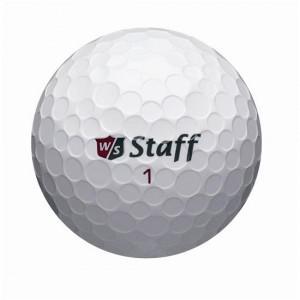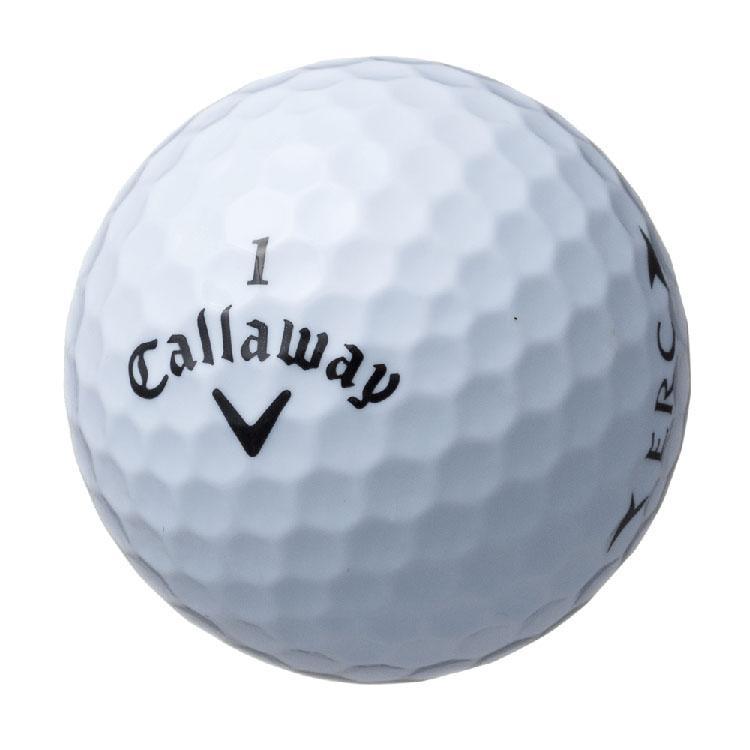The first image is the image on the left, the second image is the image on the right. Given the left and right images, does the statement "In one of the images there is a golf ball with a face printed on it." hold true? Answer yes or no. No. The first image is the image on the left, the second image is the image on the right. Assess this claim about the two images: "Exactly one standard white golf ball is shown in each image, with its brand name stamped in black and a number either above or below it.". Correct or not? Answer yes or no. Yes. 